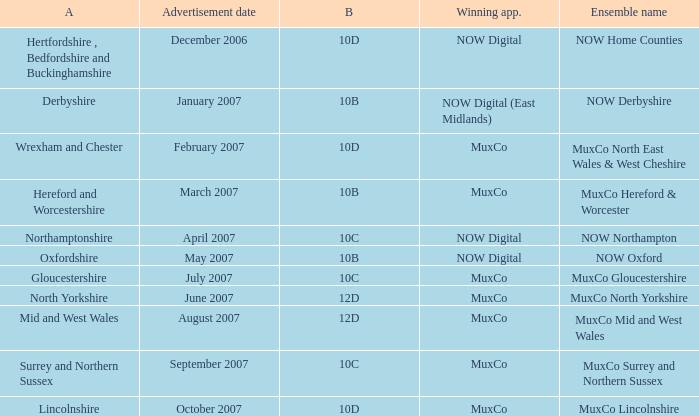Who has been declared the successful applicant for block 10b in the derbyshire region? NOW Digital (East Midlands). 